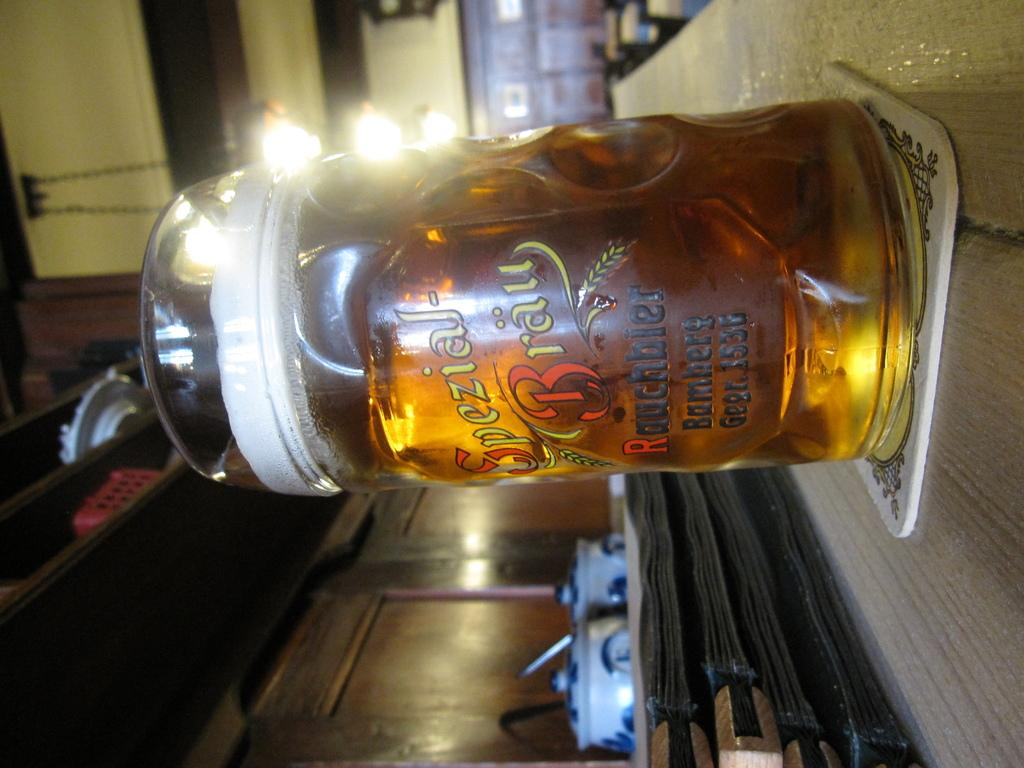<image>
Share a concise interpretation of the image provided. a glass full of liquid that has a logo that says 'spezial-brau' on it 